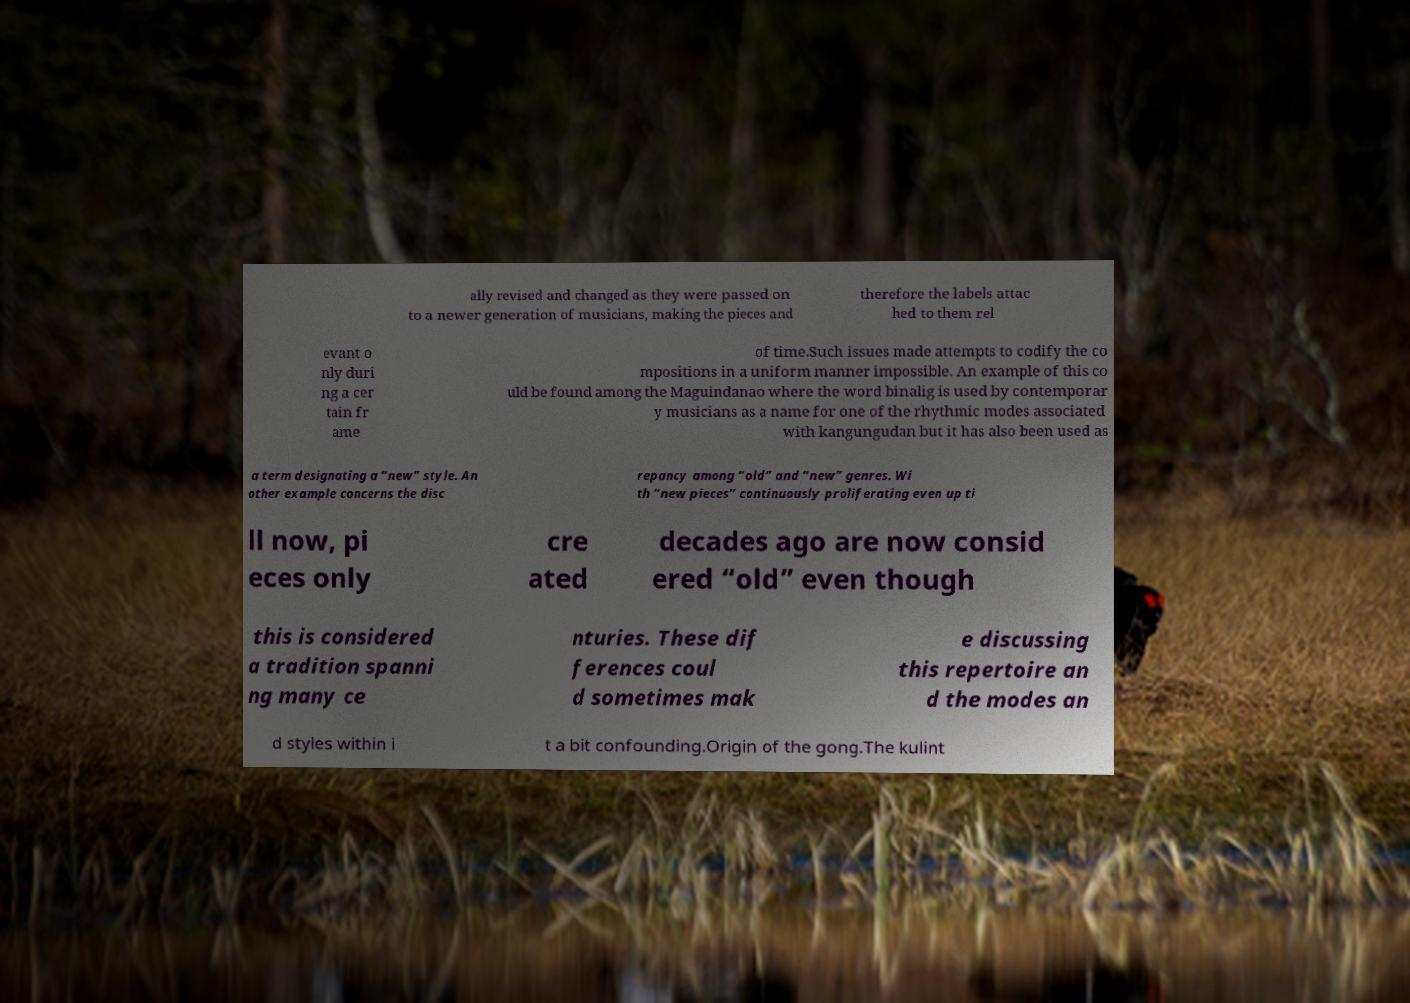For documentation purposes, I need the text within this image transcribed. Could you provide that? ally revised and changed as they were passed on to a newer generation of musicians, making the pieces and therefore the labels attac hed to them rel evant o nly duri ng a cer tain fr ame of time.Such issues made attempts to codify the co mpositions in a uniform manner impossible. An example of this co uld be found among the Maguindanao where the word binalig is used by contemporar y musicians as a name for one of the rhythmic modes associated with kangungudan but it has also been used as a term designating a “new” style. An other example concerns the disc repancy among “old” and “new” genres. Wi th “new pieces” continuously proliferating even up ti ll now, pi eces only cre ated decades ago are now consid ered “old” even though this is considered a tradition spanni ng many ce nturies. These dif ferences coul d sometimes mak e discussing this repertoire an d the modes an d styles within i t a bit confounding.Origin of the gong.The kulint 